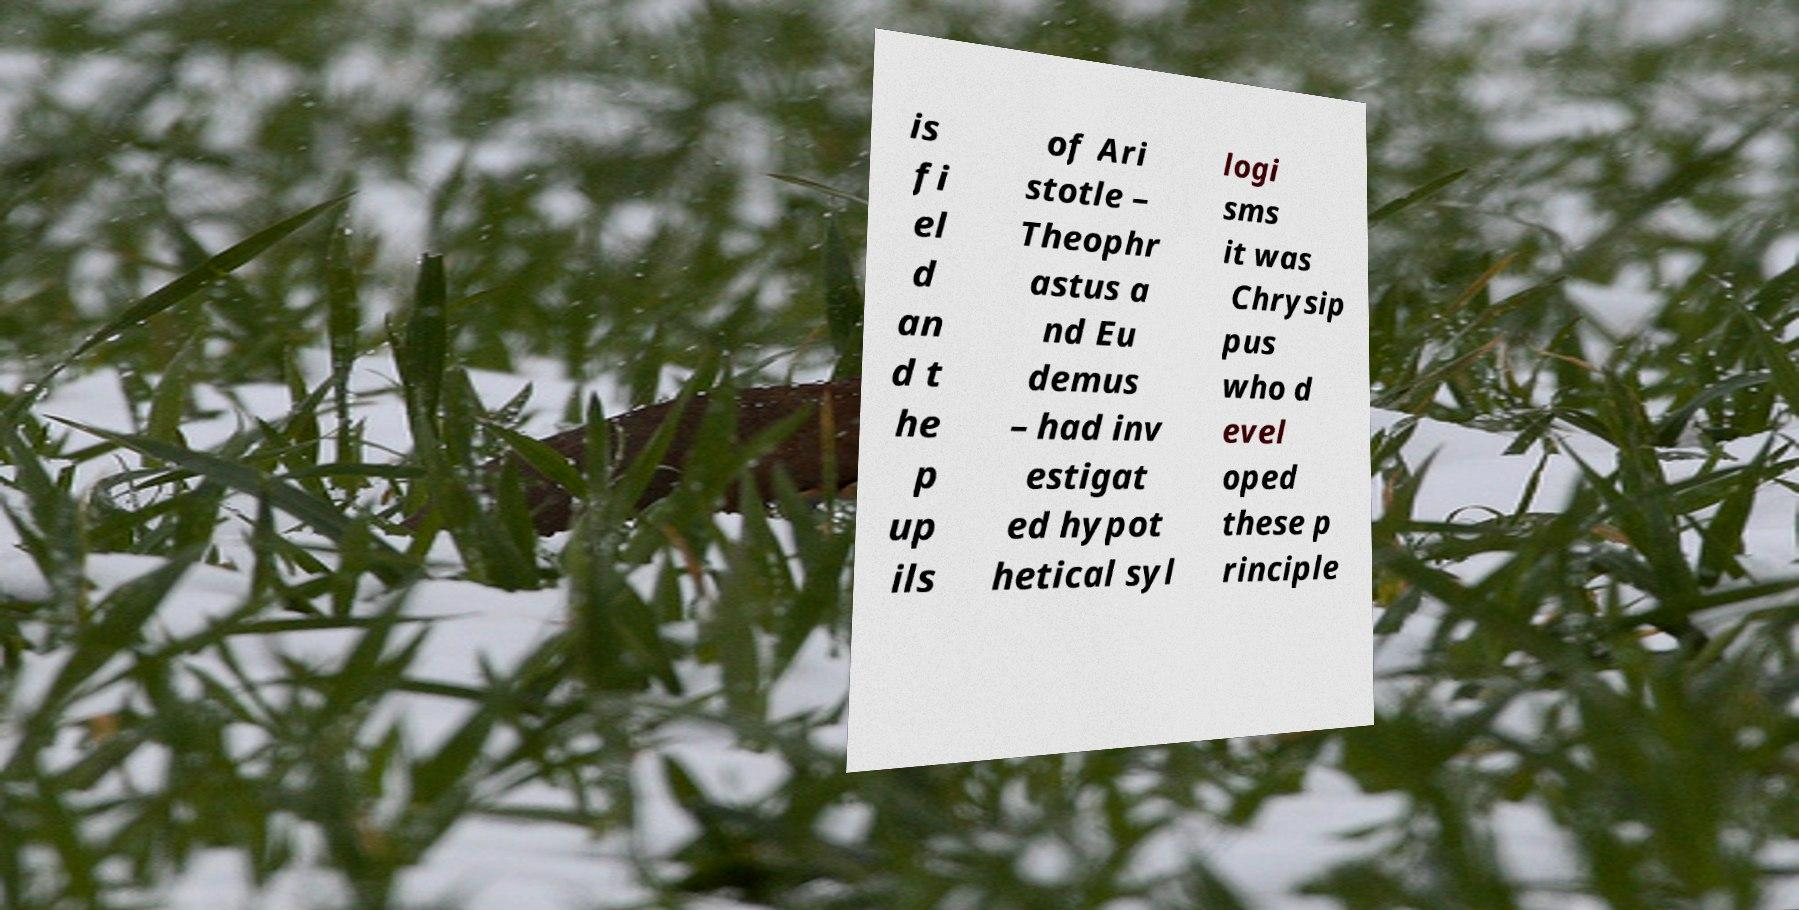Could you extract and type out the text from this image? is fi el d an d t he p up ils of Ari stotle – Theophr astus a nd Eu demus – had inv estigat ed hypot hetical syl logi sms it was Chrysip pus who d evel oped these p rinciple 